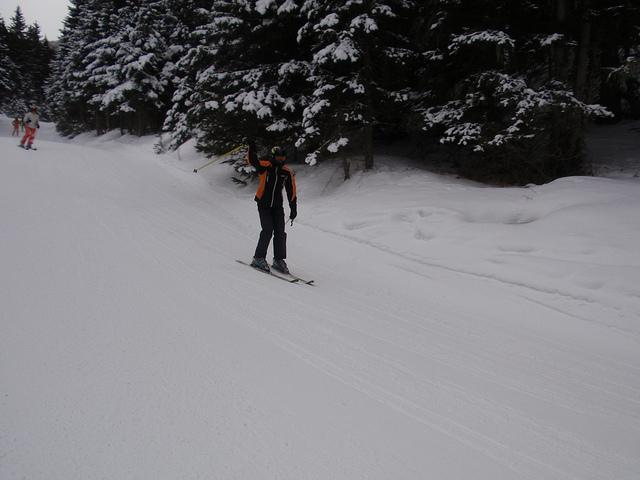Why is the man raising his arm while skiing? waving 